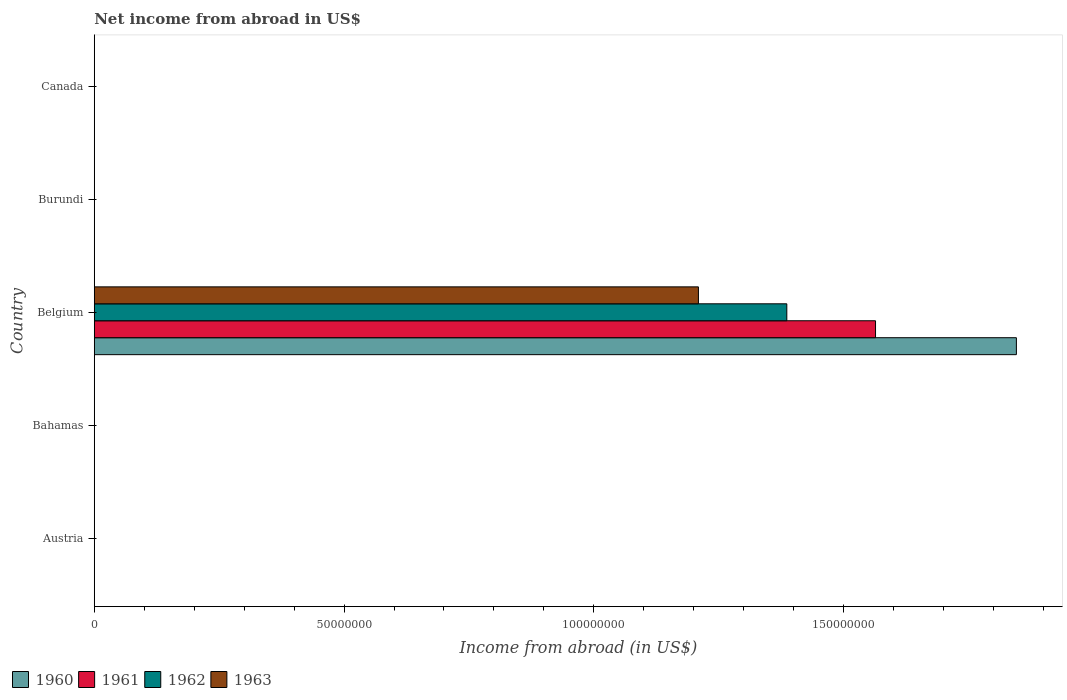How many different coloured bars are there?
Provide a short and direct response. 4. How many bars are there on the 2nd tick from the bottom?
Give a very brief answer. 0. What is the label of the 1st group of bars from the top?
Ensure brevity in your answer.  Canada. In how many cases, is the number of bars for a given country not equal to the number of legend labels?
Give a very brief answer. 4. Across all countries, what is the maximum net income from abroad in 1963?
Your response must be concise. 1.21e+08. Across all countries, what is the minimum net income from abroad in 1961?
Your response must be concise. 0. In which country was the net income from abroad in 1960 maximum?
Offer a terse response. Belgium. What is the total net income from abroad in 1962 in the graph?
Your answer should be very brief. 1.39e+08. What is the difference between the net income from abroad in 1963 in Austria and the net income from abroad in 1962 in Belgium?
Offer a terse response. -1.39e+08. What is the average net income from abroad in 1961 per country?
Provide a short and direct response. 3.13e+07. What is the difference between the net income from abroad in 1963 and net income from abroad in 1960 in Belgium?
Your answer should be very brief. -6.37e+07. In how many countries, is the net income from abroad in 1962 greater than 120000000 US$?
Your answer should be very brief. 1. What is the difference between the highest and the lowest net income from abroad in 1963?
Offer a terse response. 1.21e+08. Is it the case that in every country, the sum of the net income from abroad in 1961 and net income from abroad in 1960 is greater than the sum of net income from abroad in 1963 and net income from abroad in 1962?
Offer a terse response. No. Is it the case that in every country, the sum of the net income from abroad in 1963 and net income from abroad in 1962 is greater than the net income from abroad in 1960?
Your answer should be very brief. No. How many bars are there?
Provide a succinct answer. 4. Are all the bars in the graph horizontal?
Offer a very short reply. Yes. How many countries are there in the graph?
Offer a terse response. 5. What is the difference between two consecutive major ticks on the X-axis?
Keep it short and to the point. 5.00e+07. Are the values on the major ticks of X-axis written in scientific E-notation?
Provide a short and direct response. No. What is the title of the graph?
Keep it short and to the point. Net income from abroad in US$. What is the label or title of the X-axis?
Keep it short and to the point. Income from abroad (in US$). What is the label or title of the Y-axis?
Provide a short and direct response. Country. What is the Income from abroad (in US$) of 1962 in Austria?
Your response must be concise. 0. What is the Income from abroad (in US$) in 1963 in Austria?
Your answer should be compact. 0. What is the Income from abroad (in US$) of 1960 in Belgium?
Provide a short and direct response. 1.85e+08. What is the Income from abroad (in US$) in 1961 in Belgium?
Provide a short and direct response. 1.56e+08. What is the Income from abroad (in US$) of 1962 in Belgium?
Your answer should be compact. 1.39e+08. What is the Income from abroad (in US$) in 1963 in Belgium?
Provide a succinct answer. 1.21e+08. What is the Income from abroad (in US$) in 1960 in Canada?
Ensure brevity in your answer.  0. What is the Income from abroad (in US$) in 1962 in Canada?
Ensure brevity in your answer.  0. What is the Income from abroad (in US$) in 1963 in Canada?
Offer a terse response. 0. Across all countries, what is the maximum Income from abroad (in US$) of 1960?
Make the answer very short. 1.85e+08. Across all countries, what is the maximum Income from abroad (in US$) of 1961?
Ensure brevity in your answer.  1.56e+08. Across all countries, what is the maximum Income from abroad (in US$) in 1962?
Your answer should be compact. 1.39e+08. Across all countries, what is the maximum Income from abroad (in US$) in 1963?
Keep it short and to the point. 1.21e+08. Across all countries, what is the minimum Income from abroad (in US$) of 1960?
Offer a terse response. 0. What is the total Income from abroad (in US$) of 1960 in the graph?
Provide a short and direct response. 1.85e+08. What is the total Income from abroad (in US$) of 1961 in the graph?
Keep it short and to the point. 1.56e+08. What is the total Income from abroad (in US$) of 1962 in the graph?
Provide a short and direct response. 1.39e+08. What is the total Income from abroad (in US$) in 1963 in the graph?
Your answer should be very brief. 1.21e+08. What is the average Income from abroad (in US$) in 1960 per country?
Your answer should be very brief. 3.69e+07. What is the average Income from abroad (in US$) in 1961 per country?
Provide a succinct answer. 3.13e+07. What is the average Income from abroad (in US$) of 1962 per country?
Ensure brevity in your answer.  2.77e+07. What is the average Income from abroad (in US$) of 1963 per country?
Give a very brief answer. 2.42e+07. What is the difference between the Income from abroad (in US$) in 1960 and Income from abroad (in US$) in 1961 in Belgium?
Give a very brief answer. 2.82e+07. What is the difference between the Income from abroad (in US$) in 1960 and Income from abroad (in US$) in 1962 in Belgium?
Your answer should be compact. 4.60e+07. What is the difference between the Income from abroad (in US$) of 1960 and Income from abroad (in US$) of 1963 in Belgium?
Offer a very short reply. 6.37e+07. What is the difference between the Income from abroad (in US$) in 1961 and Income from abroad (in US$) in 1962 in Belgium?
Make the answer very short. 1.78e+07. What is the difference between the Income from abroad (in US$) of 1961 and Income from abroad (in US$) of 1963 in Belgium?
Give a very brief answer. 3.55e+07. What is the difference between the Income from abroad (in US$) in 1962 and Income from abroad (in US$) in 1963 in Belgium?
Your response must be concise. 1.77e+07. What is the difference between the highest and the lowest Income from abroad (in US$) of 1960?
Your answer should be compact. 1.85e+08. What is the difference between the highest and the lowest Income from abroad (in US$) in 1961?
Your answer should be compact. 1.56e+08. What is the difference between the highest and the lowest Income from abroad (in US$) of 1962?
Ensure brevity in your answer.  1.39e+08. What is the difference between the highest and the lowest Income from abroad (in US$) in 1963?
Provide a short and direct response. 1.21e+08. 